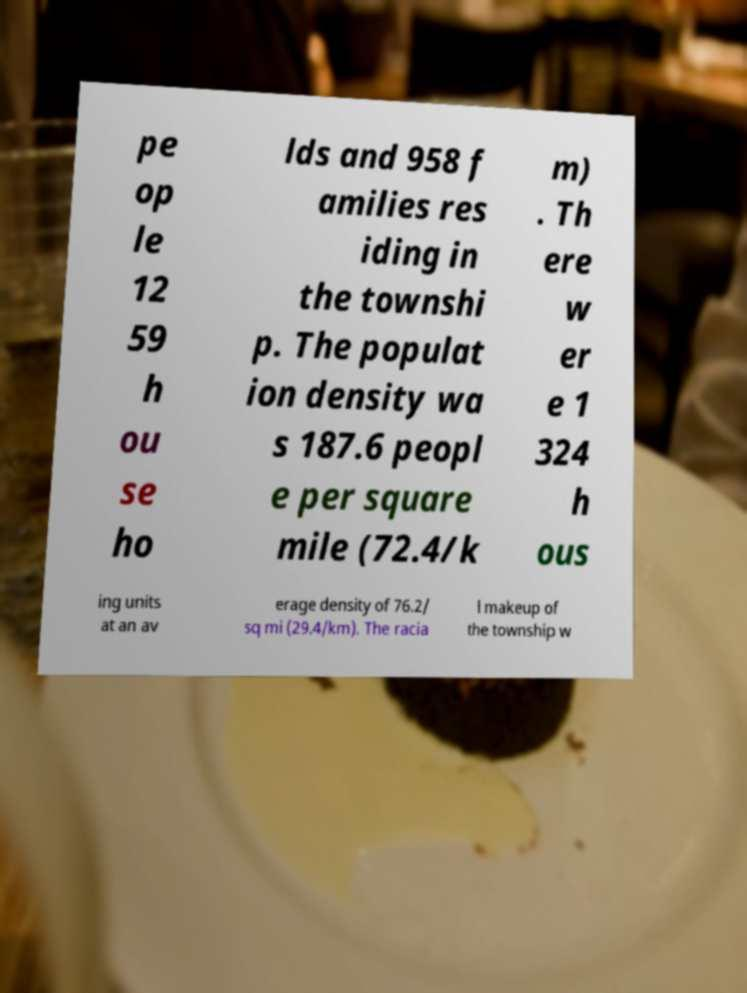Could you extract and type out the text from this image? pe op le 12 59 h ou se ho lds and 958 f amilies res iding in the townshi p. The populat ion density wa s 187.6 peopl e per square mile (72.4/k m) . Th ere w er e 1 324 h ous ing units at an av erage density of 76.2/ sq mi (29.4/km). The racia l makeup of the township w 